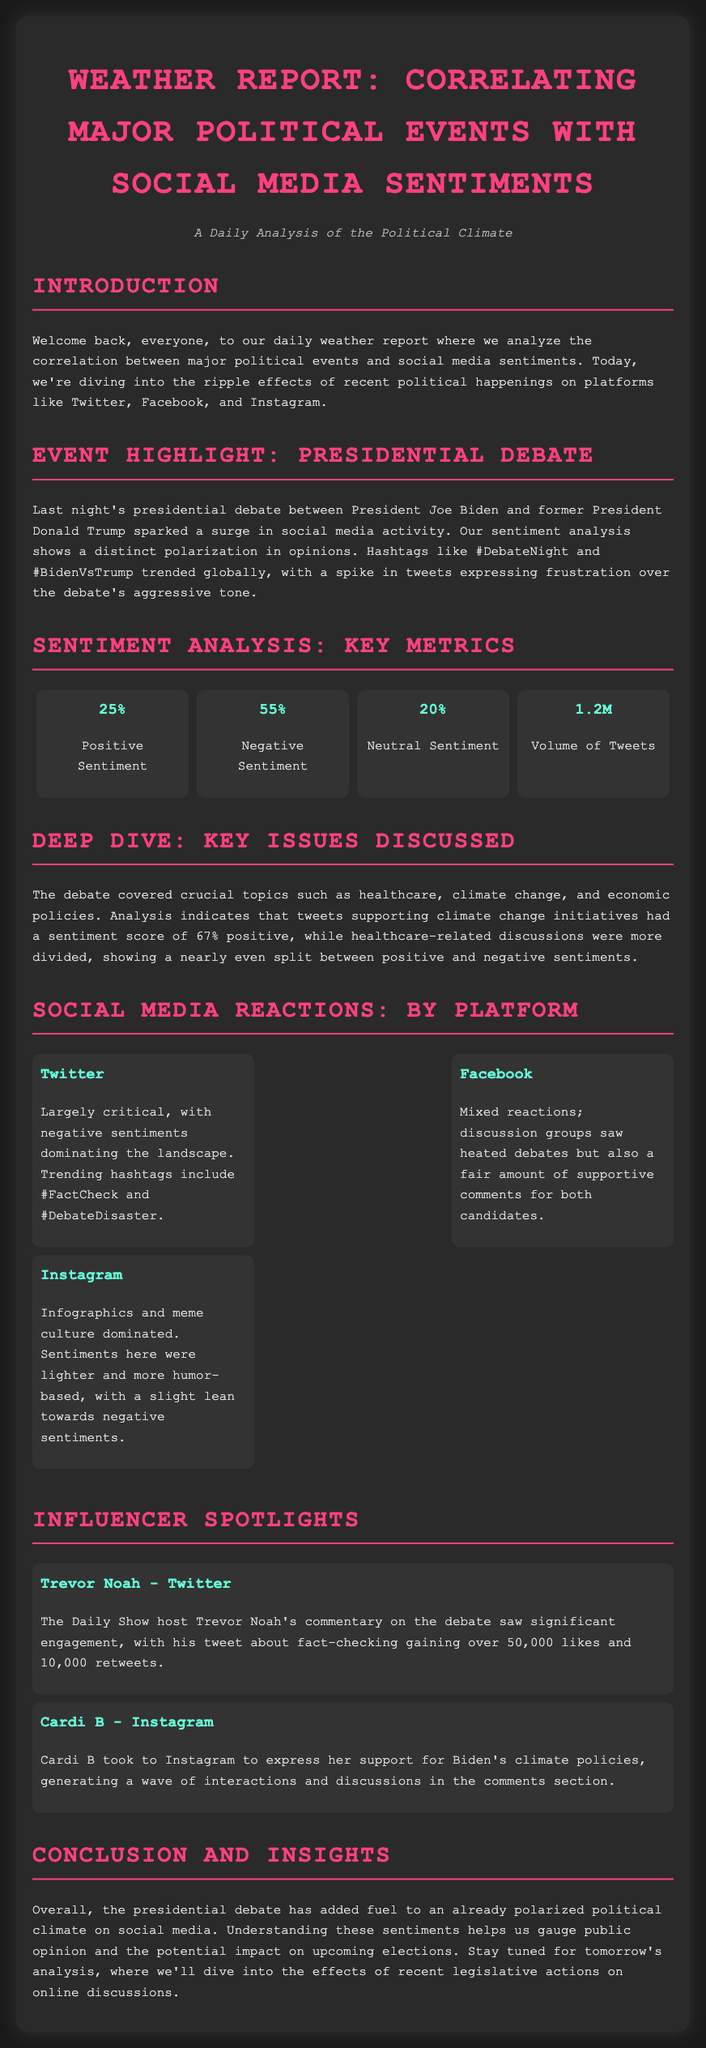what was the positive sentiment percentage? The document states that positive sentiment is measured at 25%.
Answer: 25% what were the trending hashtags during the debate? The document lists the trending hashtags as #DebateNight and #BidenVsTrump.
Answer: #DebateNight, #BidenVsTrump what was the volume of tweets recorded? The document reports a total volume of tweets as 1.2 million.
Answer: 1.2M which topic had a higher positive sentiment score? According to the analysis, climate change initiatives had a positive sentiment score of 67%, higher than healthcare discussions.
Answer: Climate change initiatives what kind of reactions did Instagram users predominantly express? The document indicates that Instagram reactions were lighter and more humor-based, with a slight lean towards negative sentiments.
Answer: Lighter and more humor-based what was a notable influencer on Twitter mentioned in the report? The report highlights Trevor Noah as a notable influencer on Twitter regarding the debate.
Answer: Trevor Noah how were sentiments characterized on Facebook? The document describes Facebook sentiments as mixed, with heated debates and supportive comments for both candidates.
Answer: Mixed what key issue discussions were mentioned as being divided? The document mentions that healthcare-related discussions showed a nearly even split between positive and negative sentiments.
Answer: Healthcare-related discussions 